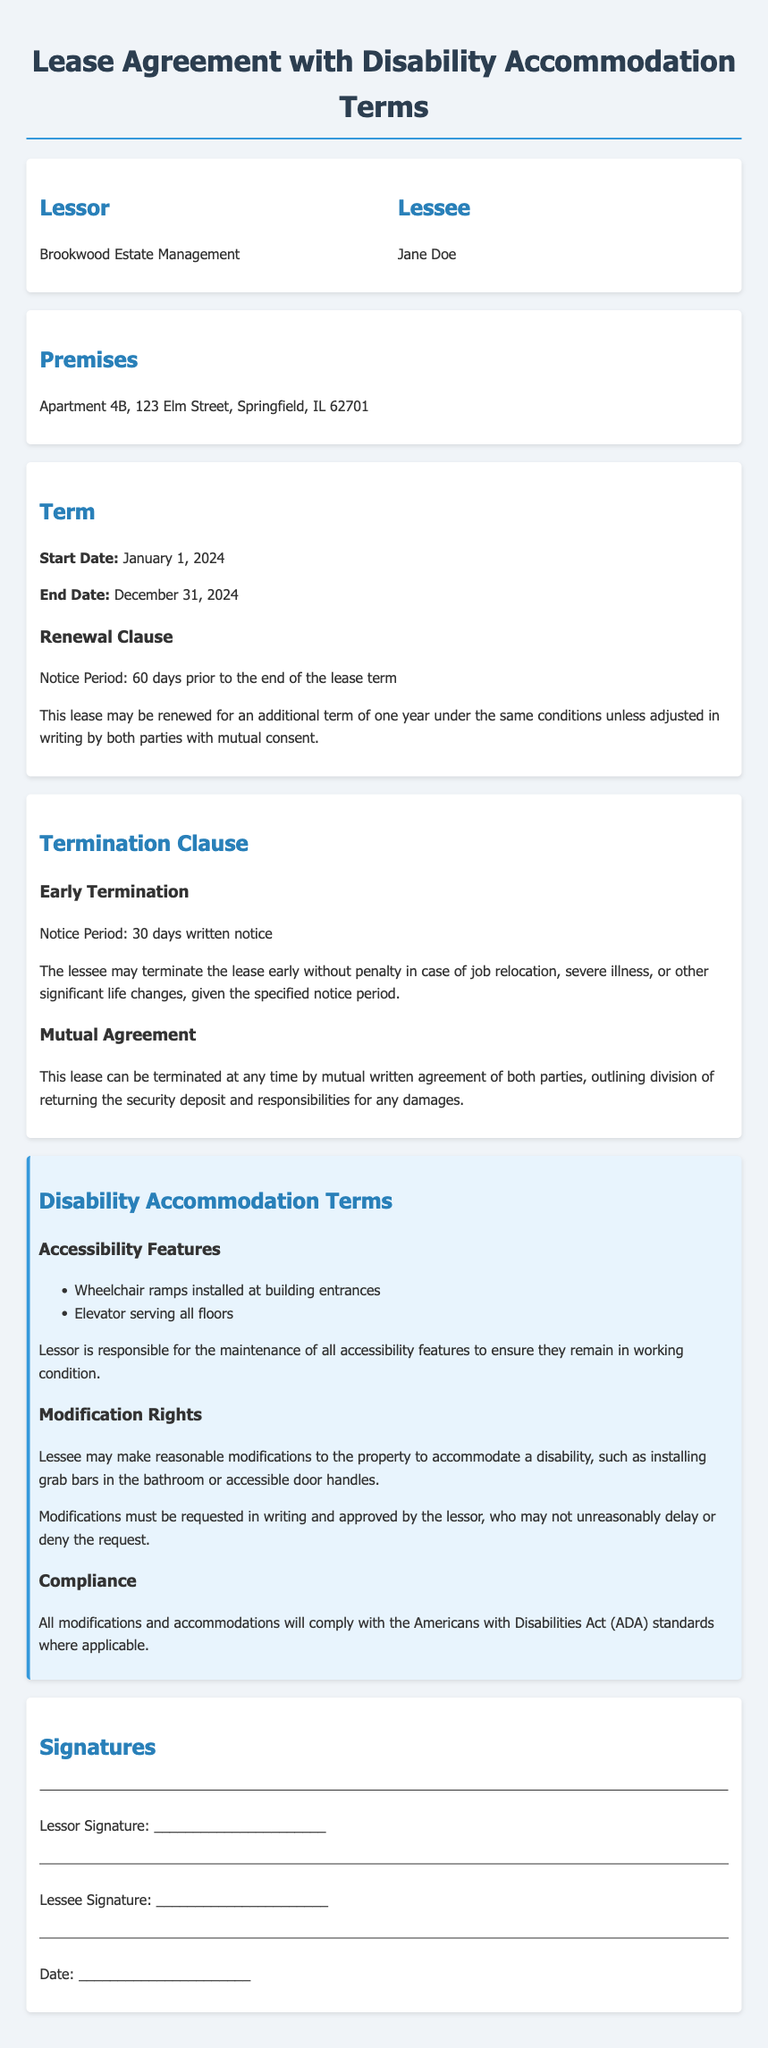What is the start date of the lease? The start date is specified in the document under the term section.
Answer: January 1, 2024 What is the notice period for renewal of the lease? The renewal notice period is mentioned explicitly in the lease agreement.
Answer: 60 days What is the lessee's name? The lessee's name is stated in the parties section of the document.
Answer: Jane Doe What are the two accessibility features listed? The document includes a specific list of accessibility features provided by the lessor.
Answer: Wheelchair ramps and elevator How long is the lease term? The lease term duration is mentioned in the term section of the document.
Answer: One year What is required for early termination of the lease? The early termination conditions specify what the lessee must provide.
Answer: 30 days written notice What must be included in the written request for modifications? The modification rights detail what is needed for lessee requests within the disability accommodation terms.
Answer: Reasonable modifications Which act must the modifications comply with? The compliance section of the disability accommodation terms points to a specific regulation.
Answer: Americans with Disabilities Act (ADA) What must happen for mutual termination of the lease? The mutual agreement clause outlines the requirements for both parties regarding lease termination.
Answer: Written agreement 